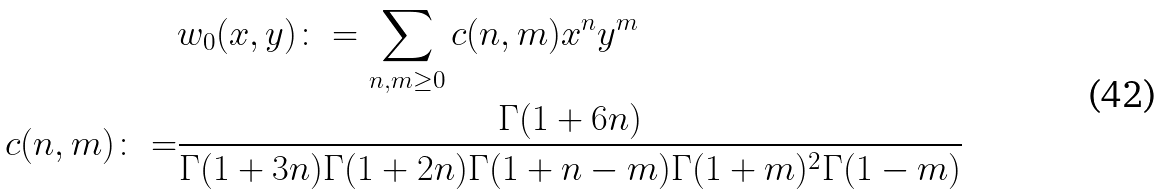Convert formula to latex. <formula><loc_0><loc_0><loc_500><loc_500>& w _ { 0 } ( x , y ) \colon = \sum _ { n , m \geq 0 } c ( n , m ) x ^ { n } y ^ { m } \\ c ( n , m ) \colon = & \frac { \Gamma ( 1 + 6 n ) } { \Gamma ( 1 + 3 n ) \Gamma ( 1 + 2 n ) \Gamma ( 1 + n - m ) \Gamma ( 1 + m ) ^ { 2 } \Gamma ( 1 - m ) }</formula> 